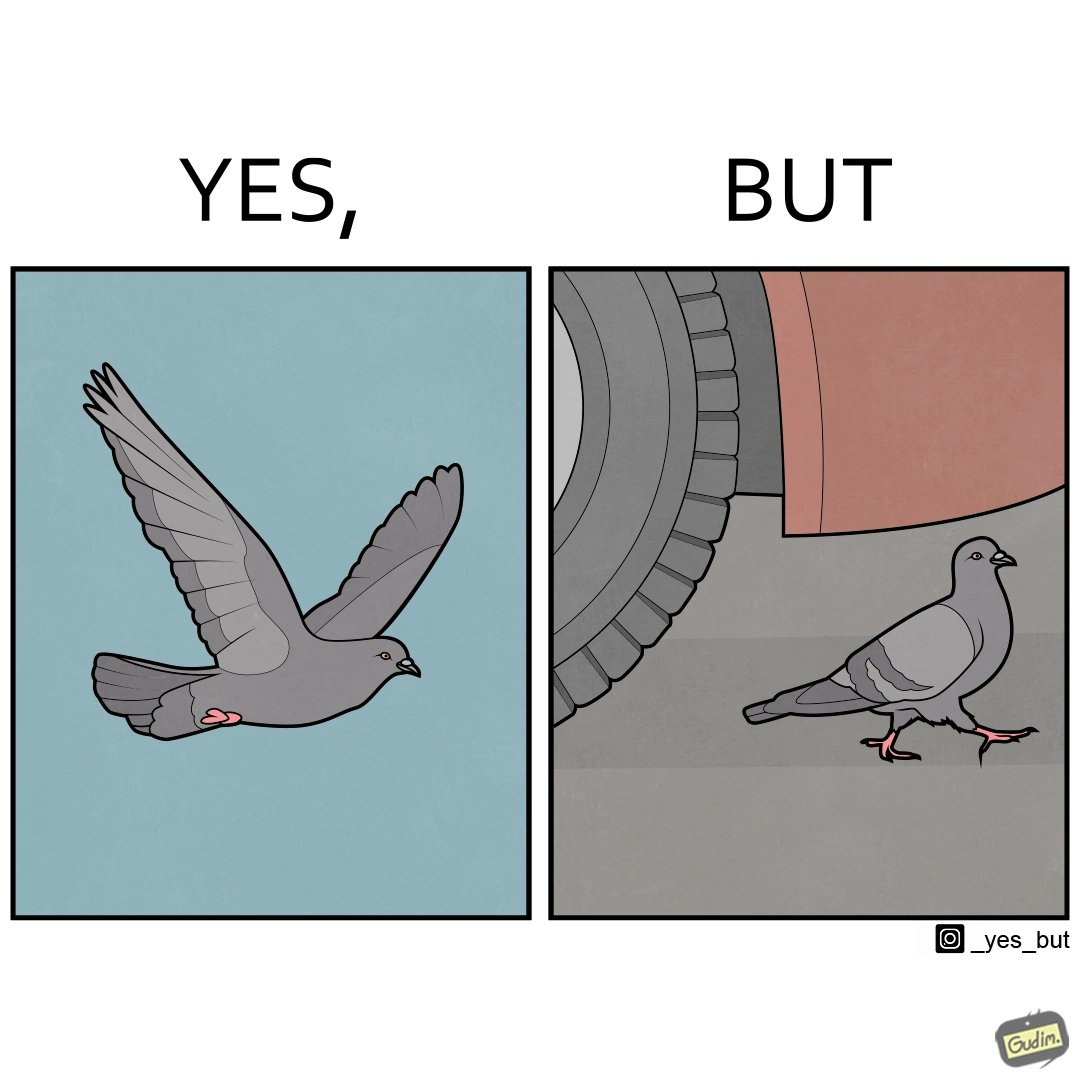Describe what you see in the left and right parts of this image. In the left part of the image: a grey pigeon flying in the sky In the right part of the image: a grey pigeon walking under a car 